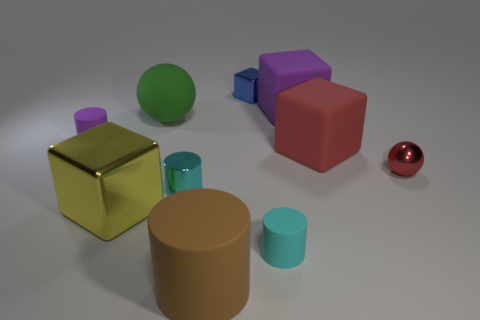How many objects are in the image, and do they vary in size? The image contains nine objects, and they vary in size ranging from small to large. Can you identify the colors of the various objects? Certainly! The colors include yellow, brown, red, green, pink, purple, blue, cyan, and beige. 